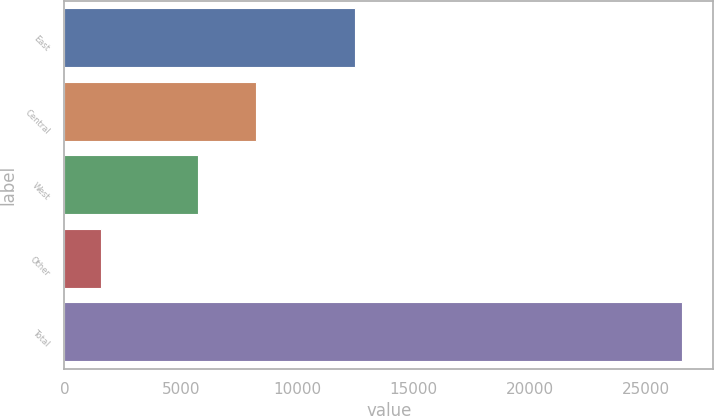Convert chart to OTSL. <chart><loc_0><loc_0><loc_500><loc_500><bar_chart><fcel>East<fcel>Central<fcel>West<fcel>Other<fcel>Total<nl><fcel>12483<fcel>8234.5<fcel>5734<fcel>1558<fcel>26563<nl></chart> 